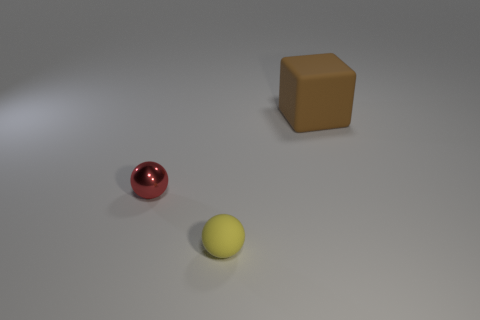The brown rubber thing is what size?
Keep it short and to the point. Large. There is a rubber thing behind the yellow rubber object; how big is it?
Your answer should be compact. Large. There is a matte thing behind the yellow ball; is it the same size as the small red shiny thing?
Provide a succinct answer. No. What shape is the large rubber object?
Your answer should be compact. Cube. What number of spheres are both to the left of the rubber sphere and on the right side of the shiny object?
Offer a very short reply. 0. What is the material of the other small thing that is the same shape as the metallic object?
Offer a terse response. Rubber. Is there anything else that is the same material as the tiny red thing?
Ensure brevity in your answer.  No. Are there an equal number of large matte objects that are right of the matte block and big brown blocks to the right of the yellow rubber object?
Give a very brief answer. No. Does the brown thing have the same material as the small red ball?
Your answer should be very brief. No. How many red objects are matte balls or blocks?
Offer a very short reply. 0. 